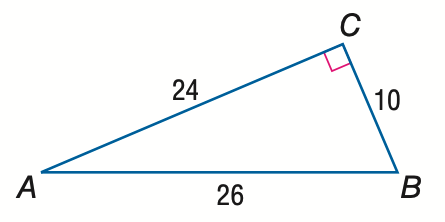Answer the mathemtical geometry problem and directly provide the correct option letter.
Question: Express the ratio of \sin A as a decimal to the nearest hundredth.
Choices: A: 0.38 B: 0.42 C: 0.92 D: 2.40 A 